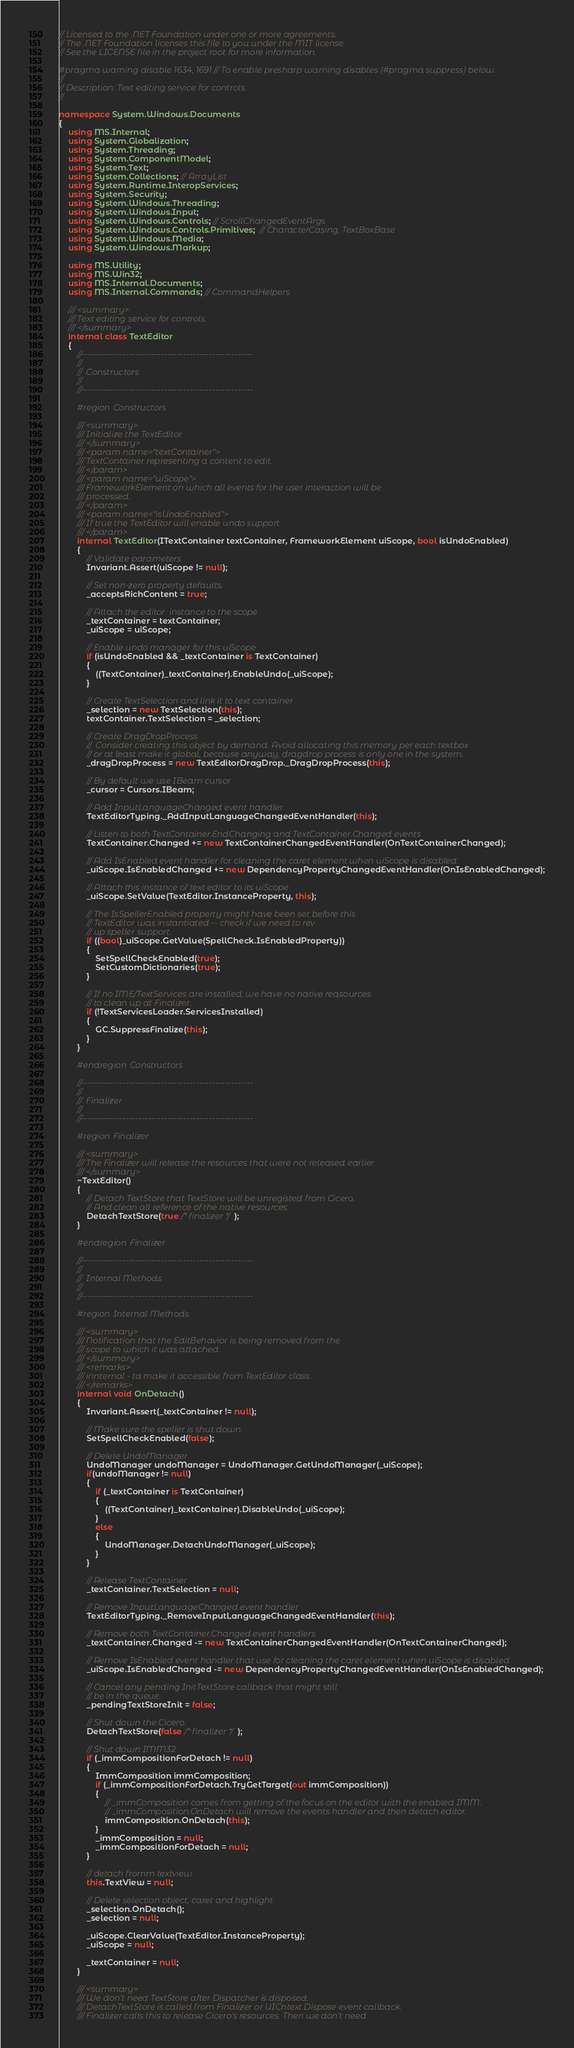<code> <loc_0><loc_0><loc_500><loc_500><_C#_>// Licensed to the .NET Foundation under one or more agreements.
// The .NET Foundation licenses this file to you under the MIT license.
// See the LICENSE file in the project root for more information.

#pragma warning disable 1634, 1691 // To enable presharp warning disables (#pragma suppress) below.
//
// Description: Text editing service for controls.
//

namespace System.Windows.Documents
{
    using MS.Internal;
    using System.Globalization;
    using System.Threading;
    using System.ComponentModel;
    using System.Text;
    using System.Collections; // ArrayList
    using System.Runtime.InteropServices;
    using System.Security;
    using System.Windows.Threading;
    using System.Windows.Input;
    using System.Windows.Controls; // ScrollChangedEventArgs
    using System.Windows.Controls.Primitives;  // CharacterCasing, TextBoxBase
    using System.Windows.Media;
    using System.Windows.Markup;

    using MS.Utility;
    using MS.Win32;
    using MS.Internal.Documents;
    using MS.Internal.Commands; // CommandHelpers

    /// <summary>
    /// Text editing service for controls.
    /// </summary>
    internal class TextEditor
    {
        //------------------------------------------------------
        //
        //  Constructors
        //
        //------------------------------------------------------

        #region Constructors

        /// <summary>
        /// Initialize the TextEditor
        /// </summary>
        /// <param name="textContainer">
        /// TextContainer representing a content to edit.
        /// </param>
        /// <param name="uiScope">
        /// FrameworkElement on which all events for the user interaction will be
        /// processed.
        /// </param>
        /// <param name="isUndoEnabled">
        /// If true the TextEditor will enable undo support
        /// </param>
        internal TextEditor(ITextContainer textContainer, FrameworkElement uiScope, bool isUndoEnabled)
        {
            // Validate parameters
            Invariant.Assert(uiScope != null);

            // Set non-zero property defaults.
            _acceptsRichContent = true;

            // Attach the editor  instance to the scope
            _textContainer = textContainer;
            _uiScope = uiScope;

            // Enable undo manager for this uiScope
            if (isUndoEnabled && _textContainer is TextContainer)
            {
                ((TextContainer)_textContainer).EnableUndo(_uiScope);
            }

            // Create TextSelection and link it to text container
            _selection = new TextSelection(this);
            textContainer.TextSelection = _selection;

            // Create DragDropProcess
            //  Consider creating this object by demand. Avoid allocating this memory per each textbox
            // or at least make it global, because anyway, dragdrop process is only one in the system.
            _dragDropProcess = new TextEditorDragDrop._DragDropProcess(this);

            // By default we use IBeam cursor
            _cursor = Cursors.IBeam;

            // Add InputLanguageChanged event handler
            TextEditorTyping._AddInputLanguageChangedEventHandler(this);

            // Listen to both TextContainer.EndChanging and TextContainer.Changed events
            TextContainer.Changed += new TextContainerChangedEventHandler(OnTextContainerChanged);

            // Add IsEnabled event handler for cleaning the caret element when uiScope is disabled
            _uiScope.IsEnabledChanged += new DependencyPropertyChangedEventHandler(OnIsEnabledChanged);

            // Attach this instance of text editor to its uiScope
            _uiScope.SetValue(TextEditor.InstanceProperty, this);

            // The IsSpellerEnabled property might have been set before this
            // TextEditor was instantiated -- check if we need to rev
            // up speller support.
            if ((bool)_uiScope.GetValue(SpellCheck.IsEnabledProperty))
            {
                SetSpellCheckEnabled(true);
                SetCustomDictionaries(true);
            }

            // If no IME/TextServices are installed, we have no native reasources
            // to clean up at Finalizer.
            if (!TextServicesLoader.ServicesInstalled)
            {
                GC.SuppressFinalize(this);
            }
        }

        #endregion Constructors

        //------------------------------------------------------
        //
        //  Finalizer
        //
        //------------------------------------------------------

        #region Finalizer

        /// <summary>
        /// The Finalizer will release the resources that were not released earlier.
        /// </summary>
        ~TextEditor()
        {
            // Detach TextStore that TextStore will be unregisted from Cicero.
            // And clean all reference of the native resources.
            DetachTextStore(true /* finalizer */);
        }

        #endregion Finalizer

        //------------------------------------------------------
        //
        //  Internal Methods
        //
        //------------------------------------------------------

        #region Internal Methods

        /// <summary>
        /// Notification that the EditBehavior is being removed from the
        /// scope to which it was attached.
        /// </summary>
        /// <remarks>
        /// innternal - ta make it accessible from TextEditor class.
        /// </remarks>
        internal void OnDetach()
        {
            Invariant.Assert(_textContainer != null);

            // Make sure the speller is shut down.
            SetSpellCheckEnabled(false);

            // Delete UndoManager
            UndoManager undoManager = UndoManager.GetUndoManager(_uiScope);
            if(undoManager != null)
            {
                if (_textContainer is TextContainer)
                {
                    ((TextContainer)_textContainer).DisableUndo(_uiScope);
                }
                else
                {
                    UndoManager.DetachUndoManager(_uiScope);
                }
            }

            // Release TextContainer
            _textContainer.TextSelection = null;

            // Remove InputLanguageChanged event handler
            TextEditorTyping._RemoveInputLanguageChangedEventHandler(this);

            // Remove both TextContainer.Changed event handlers
            _textContainer.Changed -= new TextContainerChangedEventHandler(OnTextContainerChanged);

            // Remove IsEnabled event handler that use for cleaning the caret element when uiScope is disabled
            _uiScope.IsEnabledChanged -= new DependencyPropertyChangedEventHandler(OnIsEnabledChanged);

            // Cancel any pending InitTextStore callback that might still
            // be in the queue.
            _pendingTextStoreInit = false;

            // Shut down the Cicero.
            DetachTextStore(false /* finalizer */);

            // Shut down IMM32.
            if (_immCompositionForDetach != null)
            {
                ImmComposition immComposition;
                if (_immCompositionForDetach.TryGetTarget(out immComposition))
                {
                    // _immComposition comes from getting of the focus on the editor with the enabled IMM.
                    // _immComposition.OnDetach will remove the events handler and then detach editor.
                    immComposition.OnDetach(this);
                }
                _immComposition = null;
                _immCompositionForDetach = null;
            }

            // detach fromm textview
            this.TextView = null;

            // Delete selection object, caret and highlight
            _selection.OnDetach();
            _selection = null;

            _uiScope.ClearValue(TextEditor.InstanceProperty);
            _uiScope = null;

            _textContainer = null;
        }

        /// <summary>
        /// We don't need TextStore after Dispatcher is disposed.
        /// DetachTextStore is called from Finalizer or UICntext.Dispose event callback.
        /// Finalizer calls this to release Cicero's resources. Then we don't need</code> 